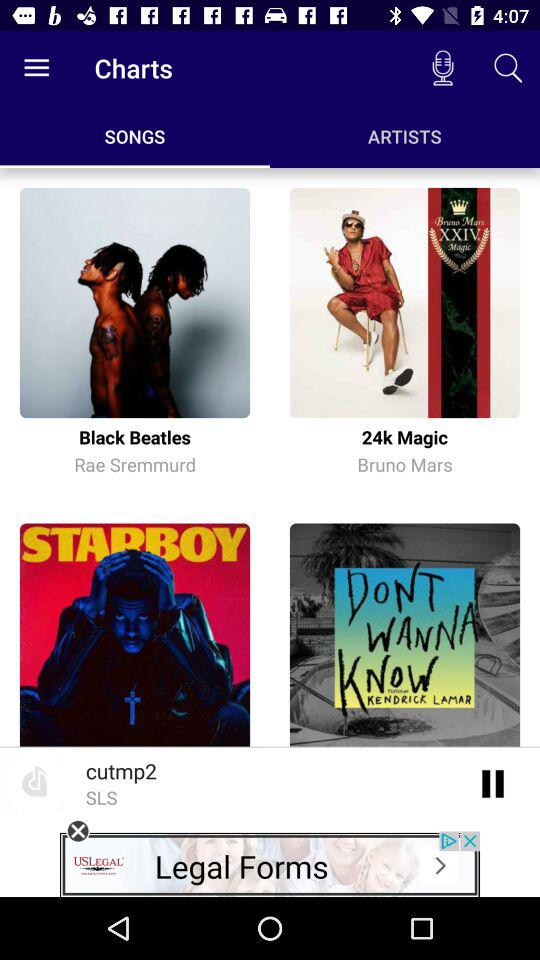Which song is marked as a favorite?
When the provided information is insufficient, respond with <no answer>. <no answer> 